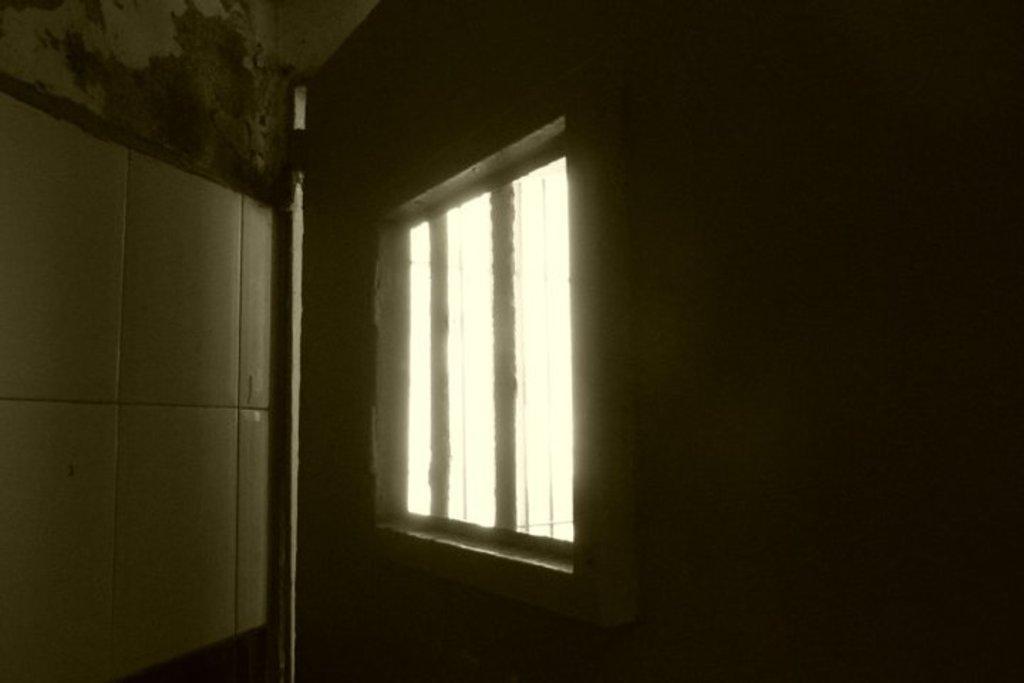Could you give a brief overview of what you see in this image? In this picture there is a window in the center of the image. 